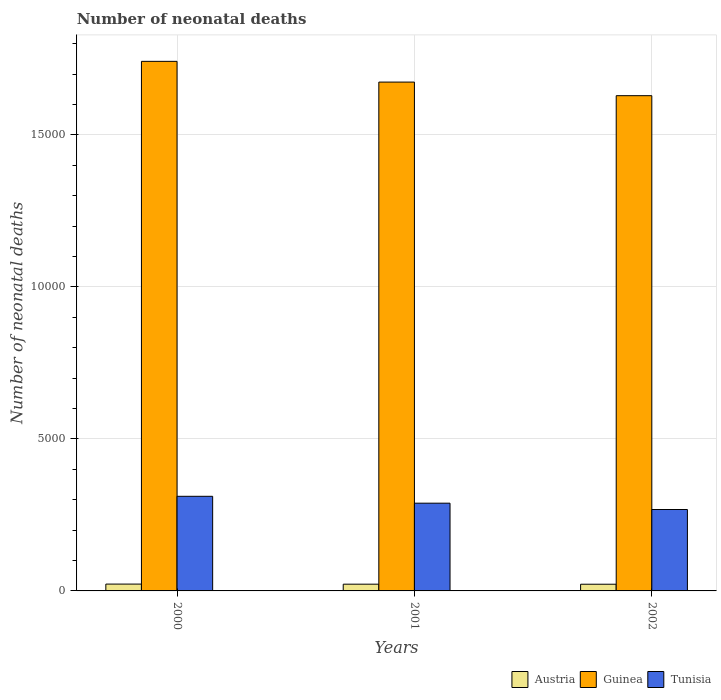How many different coloured bars are there?
Your answer should be compact. 3. Are the number of bars on each tick of the X-axis equal?
Give a very brief answer. Yes. How many bars are there on the 1st tick from the right?
Provide a short and direct response. 3. What is the label of the 2nd group of bars from the left?
Give a very brief answer. 2001. What is the number of neonatal deaths in in Guinea in 2000?
Provide a short and direct response. 1.74e+04. Across all years, what is the maximum number of neonatal deaths in in Austria?
Provide a short and direct response. 225. Across all years, what is the minimum number of neonatal deaths in in Austria?
Provide a succinct answer. 220. What is the total number of neonatal deaths in in Guinea in the graph?
Your answer should be very brief. 5.04e+04. What is the difference between the number of neonatal deaths in in Guinea in 2000 and that in 2001?
Your answer should be very brief. 682. What is the difference between the number of neonatal deaths in in Tunisia in 2000 and the number of neonatal deaths in in Austria in 2002?
Keep it short and to the point. 2892. What is the average number of neonatal deaths in in Guinea per year?
Your response must be concise. 1.68e+04. In the year 2000, what is the difference between the number of neonatal deaths in in Guinea and number of neonatal deaths in in Austria?
Ensure brevity in your answer.  1.72e+04. In how many years, is the number of neonatal deaths in in Austria greater than 8000?
Provide a short and direct response. 0. What is the ratio of the number of neonatal deaths in in Guinea in 2001 to that in 2002?
Your answer should be compact. 1.03. Is the difference between the number of neonatal deaths in in Guinea in 2000 and 2001 greater than the difference between the number of neonatal deaths in in Austria in 2000 and 2001?
Make the answer very short. Yes. What is the difference between the highest and the second highest number of neonatal deaths in in Austria?
Your answer should be very brief. 3. What is the difference between the highest and the lowest number of neonatal deaths in in Austria?
Make the answer very short. 5. Is the sum of the number of neonatal deaths in in Austria in 2001 and 2002 greater than the maximum number of neonatal deaths in in Guinea across all years?
Your response must be concise. No. What does the 3rd bar from the left in 2001 represents?
Provide a short and direct response. Tunisia. Are the values on the major ticks of Y-axis written in scientific E-notation?
Make the answer very short. No. Does the graph contain any zero values?
Provide a short and direct response. No. Does the graph contain grids?
Your answer should be very brief. Yes. Where does the legend appear in the graph?
Offer a terse response. Bottom right. How are the legend labels stacked?
Offer a terse response. Horizontal. What is the title of the graph?
Your answer should be very brief. Number of neonatal deaths. What is the label or title of the X-axis?
Give a very brief answer. Years. What is the label or title of the Y-axis?
Provide a short and direct response. Number of neonatal deaths. What is the Number of neonatal deaths in Austria in 2000?
Provide a succinct answer. 225. What is the Number of neonatal deaths of Guinea in 2000?
Offer a very short reply. 1.74e+04. What is the Number of neonatal deaths in Tunisia in 2000?
Your response must be concise. 3112. What is the Number of neonatal deaths in Austria in 2001?
Give a very brief answer. 222. What is the Number of neonatal deaths of Guinea in 2001?
Provide a short and direct response. 1.67e+04. What is the Number of neonatal deaths in Tunisia in 2001?
Give a very brief answer. 2886. What is the Number of neonatal deaths of Austria in 2002?
Offer a terse response. 220. What is the Number of neonatal deaths in Guinea in 2002?
Keep it short and to the point. 1.63e+04. What is the Number of neonatal deaths in Tunisia in 2002?
Offer a very short reply. 2678. Across all years, what is the maximum Number of neonatal deaths in Austria?
Ensure brevity in your answer.  225. Across all years, what is the maximum Number of neonatal deaths of Guinea?
Give a very brief answer. 1.74e+04. Across all years, what is the maximum Number of neonatal deaths in Tunisia?
Keep it short and to the point. 3112. Across all years, what is the minimum Number of neonatal deaths in Austria?
Keep it short and to the point. 220. Across all years, what is the minimum Number of neonatal deaths of Guinea?
Ensure brevity in your answer.  1.63e+04. Across all years, what is the minimum Number of neonatal deaths of Tunisia?
Your response must be concise. 2678. What is the total Number of neonatal deaths in Austria in the graph?
Your answer should be compact. 667. What is the total Number of neonatal deaths in Guinea in the graph?
Provide a succinct answer. 5.04e+04. What is the total Number of neonatal deaths of Tunisia in the graph?
Make the answer very short. 8676. What is the difference between the Number of neonatal deaths in Austria in 2000 and that in 2001?
Provide a short and direct response. 3. What is the difference between the Number of neonatal deaths of Guinea in 2000 and that in 2001?
Provide a short and direct response. 682. What is the difference between the Number of neonatal deaths in Tunisia in 2000 and that in 2001?
Offer a terse response. 226. What is the difference between the Number of neonatal deaths of Austria in 2000 and that in 2002?
Provide a succinct answer. 5. What is the difference between the Number of neonatal deaths in Guinea in 2000 and that in 2002?
Provide a succinct answer. 1129. What is the difference between the Number of neonatal deaths of Tunisia in 2000 and that in 2002?
Give a very brief answer. 434. What is the difference between the Number of neonatal deaths in Guinea in 2001 and that in 2002?
Offer a terse response. 447. What is the difference between the Number of neonatal deaths of Tunisia in 2001 and that in 2002?
Provide a succinct answer. 208. What is the difference between the Number of neonatal deaths of Austria in 2000 and the Number of neonatal deaths of Guinea in 2001?
Provide a short and direct response. -1.65e+04. What is the difference between the Number of neonatal deaths in Austria in 2000 and the Number of neonatal deaths in Tunisia in 2001?
Provide a short and direct response. -2661. What is the difference between the Number of neonatal deaths of Guinea in 2000 and the Number of neonatal deaths of Tunisia in 2001?
Your response must be concise. 1.45e+04. What is the difference between the Number of neonatal deaths of Austria in 2000 and the Number of neonatal deaths of Guinea in 2002?
Offer a terse response. -1.61e+04. What is the difference between the Number of neonatal deaths in Austria in 2000 and the Number of neonatal deaths in Tunisia in 2002?
Offer a very short reply. -2453. What is the difference between the Number of neonatal deaths of Guinea in 2000 and the Number of neonatal deaths of Tunisia in 2002?
Provide a short and direct response. 1.47e+04. What is the difference between the Number of neonatal deaths in Austria in 2001 and the Number of neonatal deaths in Guinea in 2002?
Ensure brevity in your answer.  -1.61e+04. What is the difference between the Number of neonatal deaths in Austria in 2001 and the Number of neonatal deaths in Tunisia in 2002?
Ensure brevity in your answer.  -2456. What is the difference between the Number of neonatal deaths in Guinea in 2001 and the Number of neonatal deaths in Tunisia in 2002?
Keep it short and to the point. 1.41e+04. What is the average Number of neonatal deaths in Austria per year?
Your response must be concise. 222.33. What is the average Number of neonatal deaths of Guinea per year?
Provide a short and direct response. 1.68e+04. What is the average Number of neonatal deaths in Tunisia per year?
Offer a terse response. 2892. In the year 2000, what is the difference between the Number of neonatal deaths of Austria and Number of neonatal deaths of Guinea?
Make the answer very short. -1.72e+04. In the year 2000, what is the difference between the Number of neonatal deaths in Austria and Number of neonatal deaths in Tunisia?
Provide a short and direct response. -2887. In the year 2000, what is the difference between the Number of neonatal deaths of Guinea and Number of neonatal deaths of Tunisia?
Give a very brief answer. 1.43e+04. In the year 2001, what is the difference between the Number of neonatal deaths of Austria and Number of neonatal deaths of Guinea?
Make the answer very short. -1.65e+04. In the year 2001, what is the difference between the Number of neonatal deaths in Austria and Number of neonatal deaths in Tunisia?
Ensure brevity in your answer.  -2664. In the year 2001, what is the difference between the Number of neonatal deaths of Guinea and Number of neonatal deaths of Tunisia?
Keep it short and to the point. 1.39e+04. In the year 2002, what is the difference between the Number of neonatal deaths in Austria and Number of neonatal deaths in Guinea?
Your response must be concise. -1.61e+04. In the year 2002, what is the difference between the Number of neonatal deaths in Austria and Number of neonatal deaths in Tunisia?
Your response must be concise. -2458. In the year 2002, what is the difference between the Number of neonatal deaths in Guinea and Number of neonatal deaths in Tunisia?
Give a very brief answer. 1.36e+04. What is the ratio of the Number of neonatal deaths in Austria in 2000 to that in 2001?
Offer a terse response. 1.01. What is the ratio of the Number of neonatal deaths of Guinea in 2000 to that in 2001?
Give a very brief answer. 1.04. What is the ratio of the Number of neonatal deaths of Tunisia in 2000 to that in 2001?
Ensure brevity in your answer.  1.08. What is the ratio of the Number of neonatal deaths of Austria in 2000 to that in 2002?
Your response must be concise. 1.02. What is the ratio of the Number of neonatal deaths in Guinea in 2000 to that in 2002?
Keep it short and to the point. 1.07. What is the ratio of the Number of neonatal deaths in Tunisia in 2000 to that in 2002?
Give a very brief answer. 1.16. What is the ratio of the Number of neonatal deaths in Austria in 2001 to that in 2002?
Give a very brief answer. 1.01. What is the ratio of the Number of neonatal deaths of Guinea in 2001 to that in 2002?
Provide a short and direct response. 1.03. What is the ratio of the Number of neonatal deaths of Tunisia in 2001 to that in 2002?
Offer a terse response. 1.08. What is the difference between the highest and the second highest Number of neonatal deaths of Austria?
Give a very brief answer. 3. What is the difference between the highest and the second highest Number of neonatal deaths in Guinea?
Provide a short and direct response. 682. What is the difference between the highest and the second highest Number of neonatal deaths in Tunisia?
Provide a short and direct response. 226. What is the difference between the highest and the lowest Number of neonatal deaths in Guinea?
Ensure brevity in your answer.  1129. What is the difference between the highest and the lowest Number of neonatal deaths of Tunisia?
Make the answer very short. 434. 